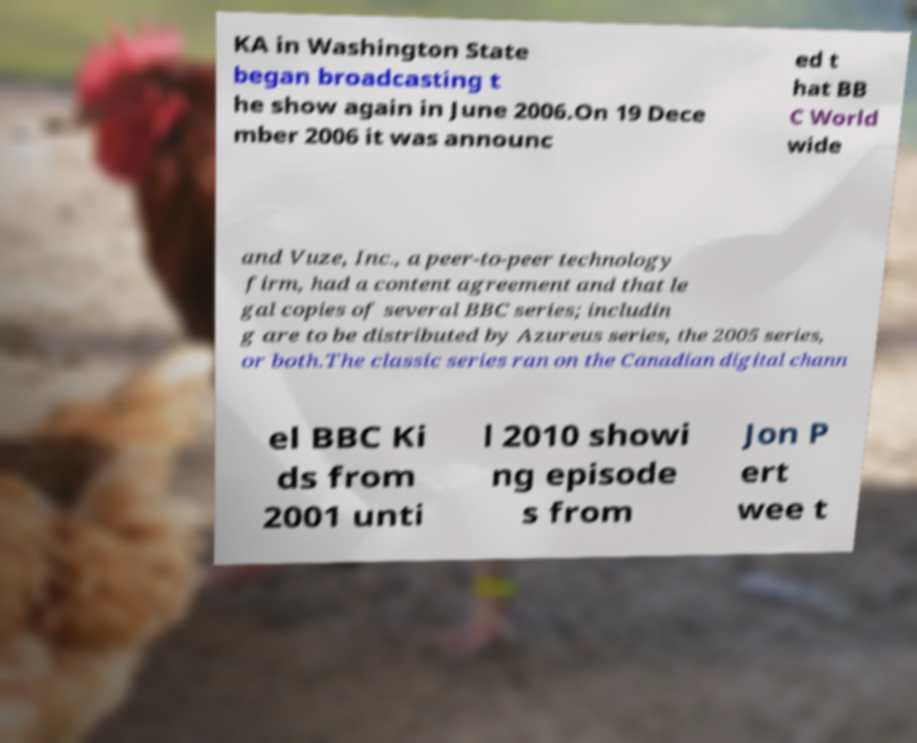For documentation purposes, I need the text within this image transcribed. Could you provide that? KA in Washington State began broadcasting t he show again in June 2006.On 19 Dece mber 2006 it was announc ed t hat BB C World wide and Vuze, Inc., a peer-to-peer technology firm, had a content agreement and that le gal copies of several BBC series; includin g are to be distributed by Azureus series, the 2005 series, or both.The classic series ran on the Canadian digital chann el BBC Ki ds from 2001 unti l 2010 showi ng episode s from Jon P ert wee t 